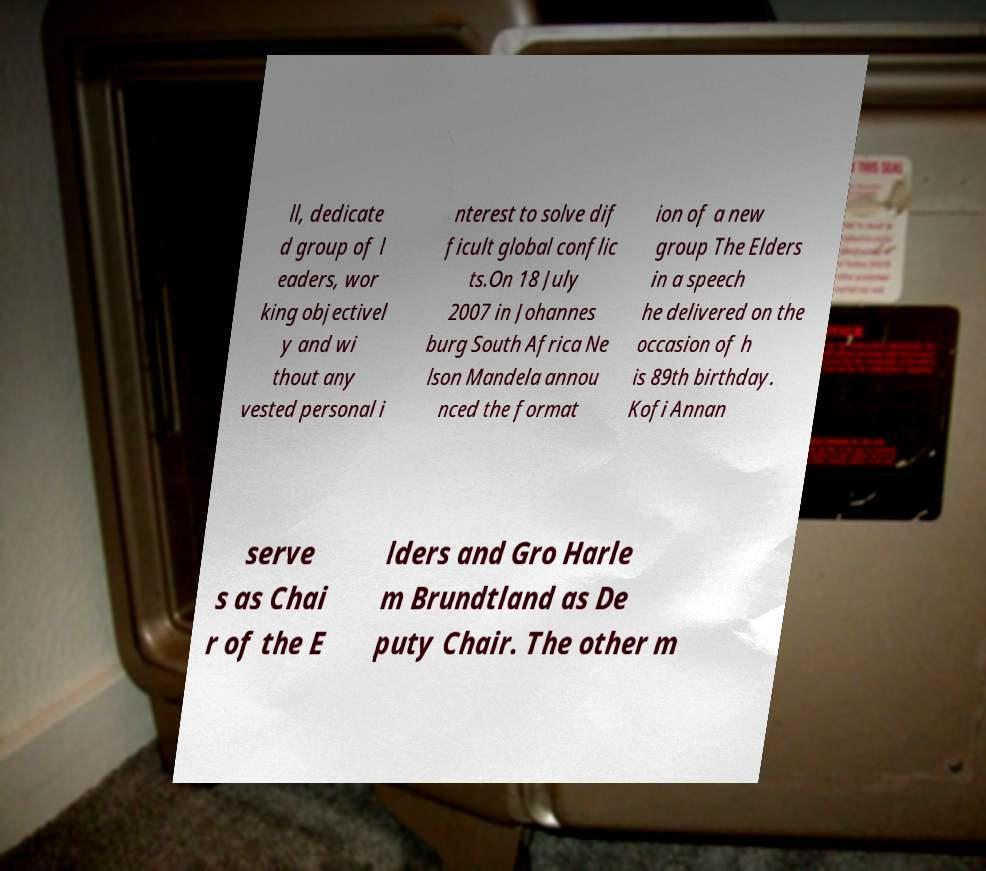There's text embedded in this image that I need extracted. Can you transcribe it verbatim? ll, dedicate d group of l eaders, wor king objectivel y and wi thout any vested personal i nterest to solve dif ficult global conflic ts.On 18 July 2007 in Johannes burg South Africa Ne lson Mandela annou nced the format ion of a new group The Elders in a speech he delivered on the occasion of h is 89th birthday. Kofi Annan serve s as Chai r of the E lders and Gro Harle m Brundtland as De puty Chair. The other m 